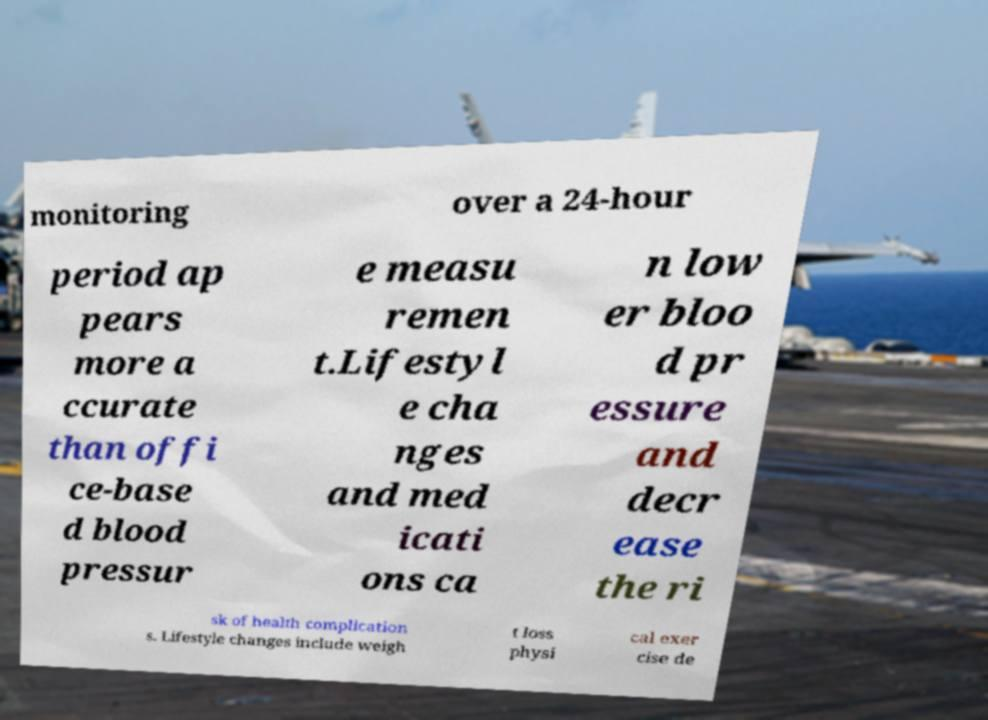Please read and relay the text visible in this image. What does it say? monitoring over a 24-hour period ap pears more a ccurate than offi ce-base d blood pressur e measu remen t.Lifestyl e cha nges and med icati ons ca n low er bloo d pr essure and decr ease the ri sk of health complication s. Lifestyle changes include weigh t loss physi cal exer cise de 